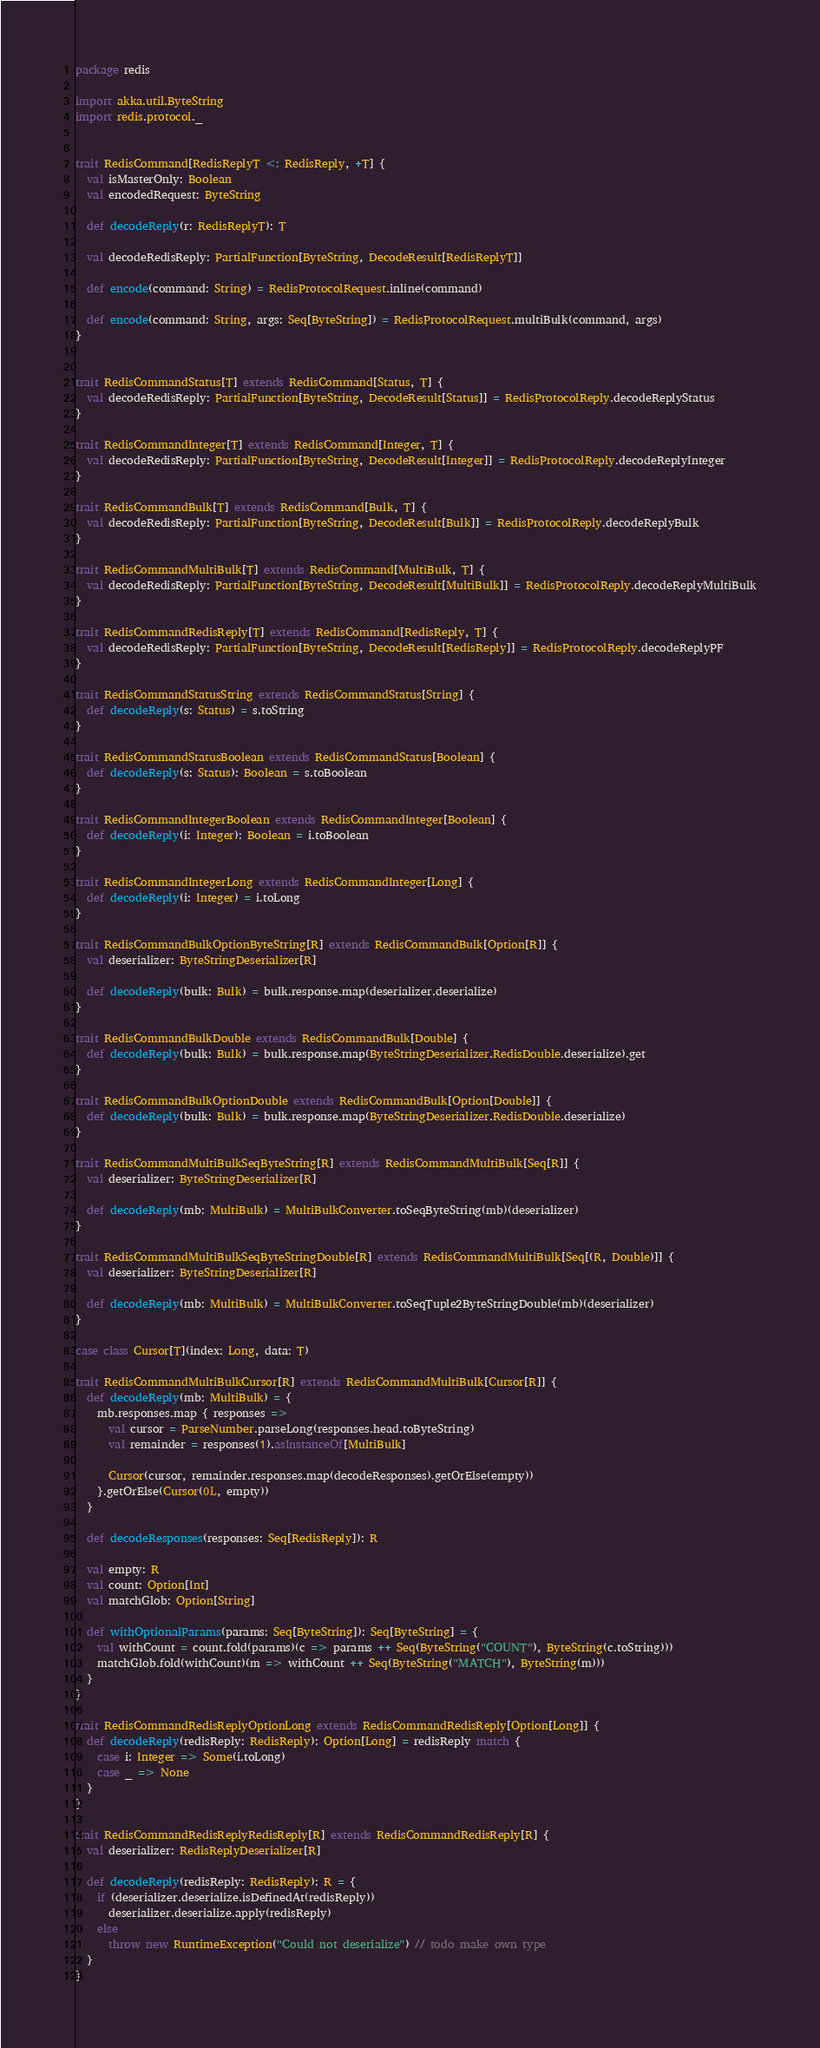<code> <loc_0><loc_0><loc_500><loc_500><_Scala_>package redis

import akka.util.ByteString
import redis.protocol._


trait RedisCommand[RedisReplyT <: RedisReply, +T] {
  val isMasterOnly: Boolean
  val encodedRequest: ByteString

  def decodeReply(r: RedisReplyT): T

  val decodeRedisReply: PartialFunction[ByteString, DecodeResult[RedisReplyT]]

  def encode(command: String) = RedisProtocolRequest.inline(command)

  def encode(command: String, args: Seq[ByteString]) = RedisProtocolRequest.multiBulk(command, args)
}


trait RedisCommandStatus[T] extends RedisCommand[Status, T] {
  val decodeRedisReply: PartialFunction[ByteString, DecodeResult[Status]] = RedisProtocolReply.decodeReplyStatus
}

trait RedisCommandInteger[T] extends RedisCommand[Integer, T] {
  val decodeRedisReply: PartialFunction[ByteString, DecodeResult[Integer]] = RedisProtocolReply.decodeReplyInteger
}

trait RedisCommandBulk[T] extends RedisCommand[Bulk, T] {
  val decodeRedisReply: PartialFunction[ByteString, DecodeResult[Bulk]] = RedisProtocolReply.decodeReplyBulk
}

trait RedisCommandMultiBulk[T] extends RedisCommand[MultiBulk, T] {
  val decodeRedisReply: PartialFunction[ByteString, DecodeResult[MultiBulk]] = RedisProtocolReply.decodeReplyMultiBulk
}

trait RedisCommandRedisReply[T] extends RedisCommand[RedisReply, T] {
  val decodeRedisReply: PartialFunction[ByteString, DecodeResult[RedisReply]] = RedisProtocolReply.decodeReplyPF
}

trait RedisCommandStatusString extends RedisCommandStatus[String] {
  def decodeReply(s: Status) = s.toString
}

trait RedisCommandStatusBoolean extends RedisCommandStatus[Boolean] {
  def decodeReply(s: Status): Boolean = s.toBoolean
}

trait RedisCommandIntegerBoolean extends RedisCommandInteger[Boolean] {
  def decodeReply(i: Integer): Boolean = i.toBoolean
}

trait RedisCommandIntegerLong extends RedisCommandInteger[Long] {
  def decodeReply(i: Integer) = i.toLong
}

trait RedisCommandBulkOptionByteString[R] extends RedisCommandBulk[Option[R]] {
  val deserializer: ByteStringDeserializer[R]

  def decodeReply(bulk: Bulk) = bulk.response.map(deserializer.deserialize)
}

trait RedisCommandBulkDouble extends RedisCommandBulk[Double] {
  def decodeReply(bulk: Bulk) = bulk.response.map(ByteStringDeserializer.RedisDouble.deserialize).get
}

trait RedisCommandBulkOptionDouble extends RedisCommandBulk[Option[Double]] {
  def decodeReply(bulk: Bulk) = bulk.response.map(ByteStringDeserializer.RedisDouble.deserialize)
}

trait RedisCommandMultiBulkSeqByteString[R] extends RedisCommandMultiBulk[Seq[R]] {
  val deserializer: ByteStringDeserializer[R]

  def decodeReply(mb: MultiBulk) = MultiBulkConverter.toSeqByteString(mb)(deserializer)
}

trait RedisCommandMultiBulkSeqByteStringDouble[R] extends RedisCommandMultiBulk[Seq[(R, Double)]] {
  val deserializer: ByteStringDeserializer[R]

  def decodeReply(mb: MultiBulk) = MultiBulkConverter.toSeqTuple2ByteStringDouble(mb)(deserializer)
}

case class Cursor[T](index: Long, data: T)

trait RedisCommandMultiBulkCursor[R] extends RedisCommandMultiBulk[Cursor[R]] {
  def decodeReply(mb: MultiBulk) = {
    mb.responses.map { responses =>
      val cursor = ParseNumber.parseLong(responses.head.toByteString)
      val remainder = responses(1).asInstanceOf[MultiBulk]

      Cursor(cursor, remainder.responses.map(decodeResponses).getOrElse(empty))
    }.getOrElse(Cursor(0L, empty))
  }

  def decodeResponses(responses: Seq[RedisReply]): R

  val empty: R
  val count: Option[Int]
  val matchGlob: Option[String]

  def withOptionalParams(params: Seq[ByteString]): Seq[ByteString] = {
    val withCount = count.fold(params)(c => params ++ Seq(ByteString("COUNT"), ByteString(c.toString)))
    matchGlob.fold(withCount)(m => withCount ++ Seq(ByteString("MATCH"), ByteString(m)))
  }
}

trait RedisCommandRedisReplyOptionLong extends RedisCommandRedisReply[Option[Long]] {
  def decodeReply(redisReply: RedisReply): Option[Long] = redisReply match {
    case i: Integer => Some(i.toLong)
    case _ => None
  }
}

trait RedisCommandRedisReplyRedisReply[R] extends RedisCommandRedisReply[R] {
  val deserializer: RedisReplyDeserializer[R]

  def decodeReply(redisReply: RedisReply): R = {
    if (deserializer.deserialize.isDefinedAt(redisReply))
      deserializer.deserialize.apply(redisReply)
    else
      throw new RuntimeException("Could not deserialize") // todo make own type
  }
}
</code> 